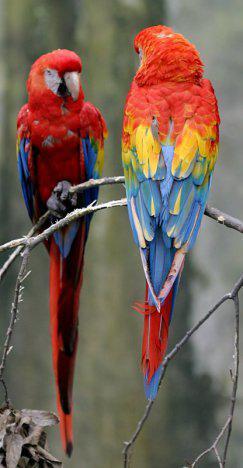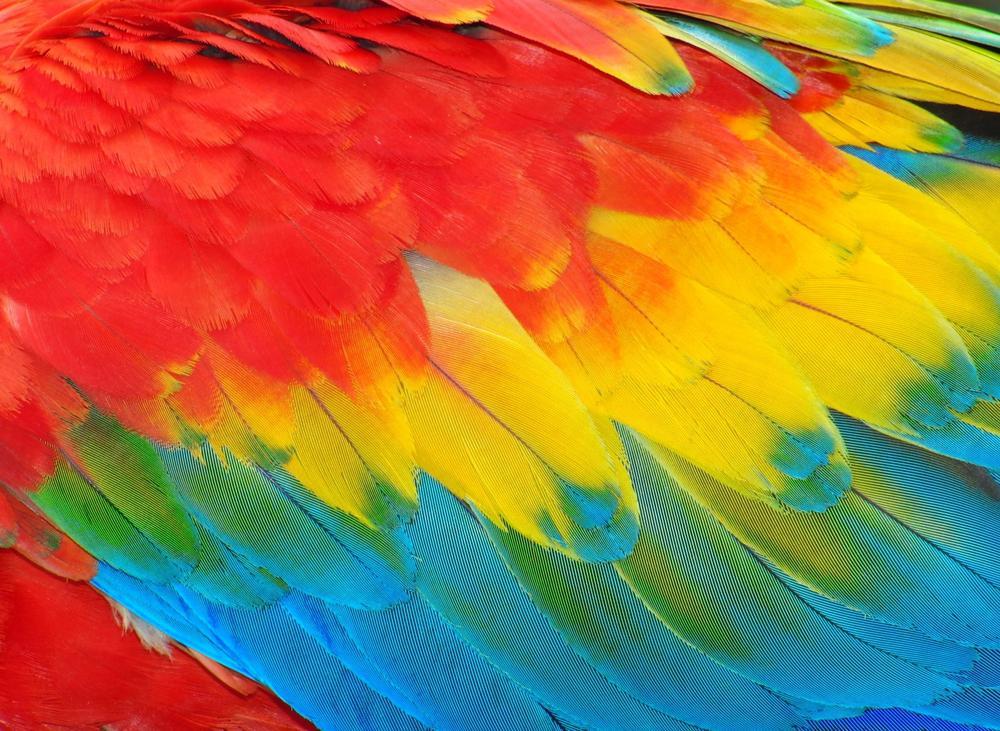The first image is the image on the left, the second image is the image on the right. Considering the images on both sides, is "You can see a Macaw's beak in the left image." valid? Answer yes or no. Yes. The first image is the image on the left, the second image is the image on the right. Examine the images to the left and right. Is the description "Atleast one photo has 2 birds" accurate? Answer yes or no. Yes. 